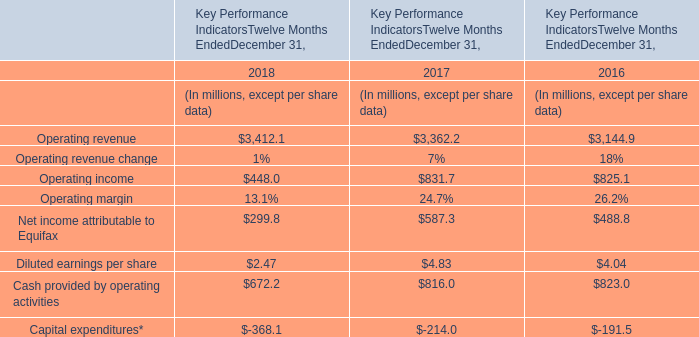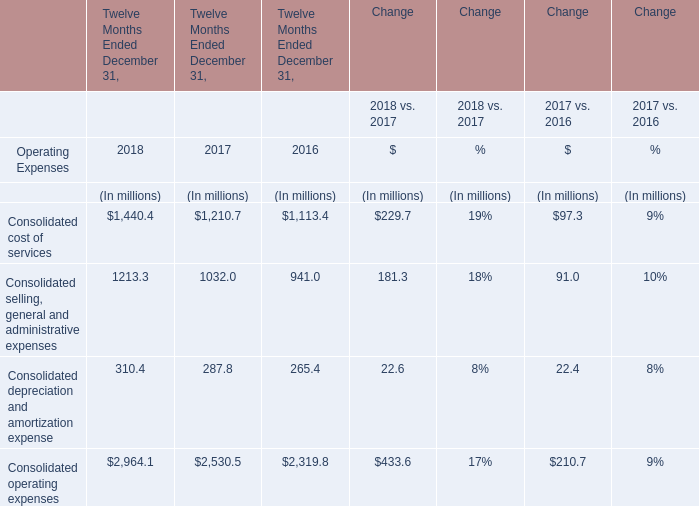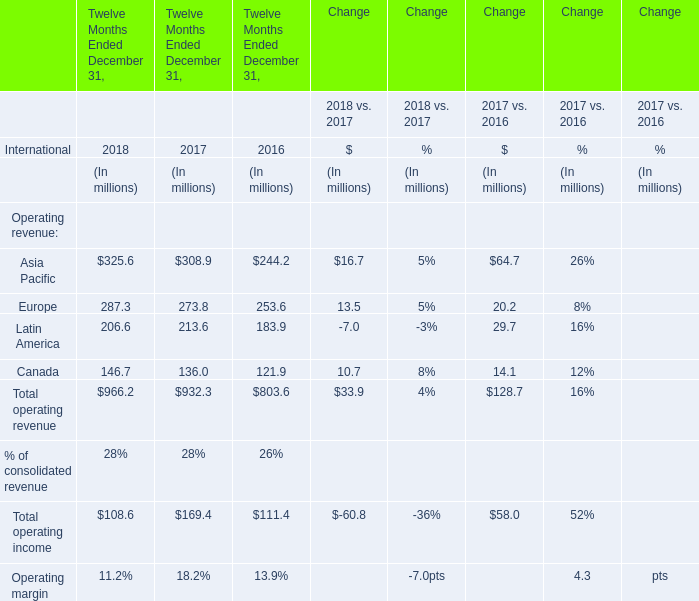How much of operating income is there in 2018 without Asia Pacific and Europe? (in millions) 
Computations: (206.6 + 146.7)
Answer: 353.3. 